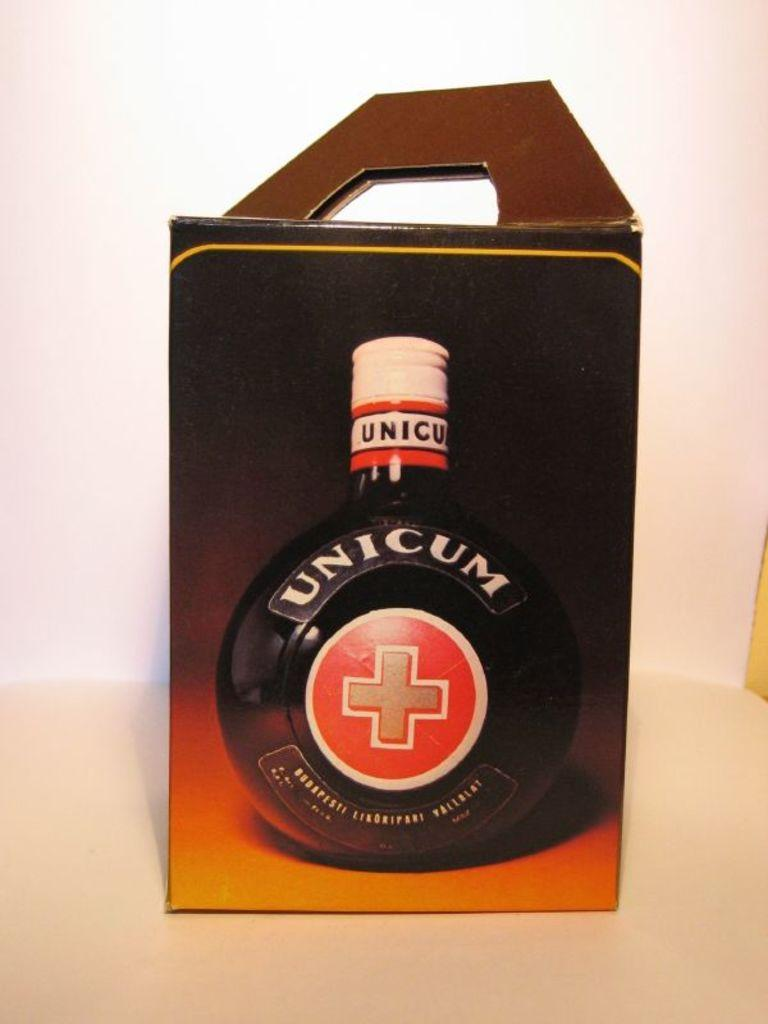<image>
Offer a succinct explanation of the picture presented. The bottle portrayed on the box is labeled Unicum. 